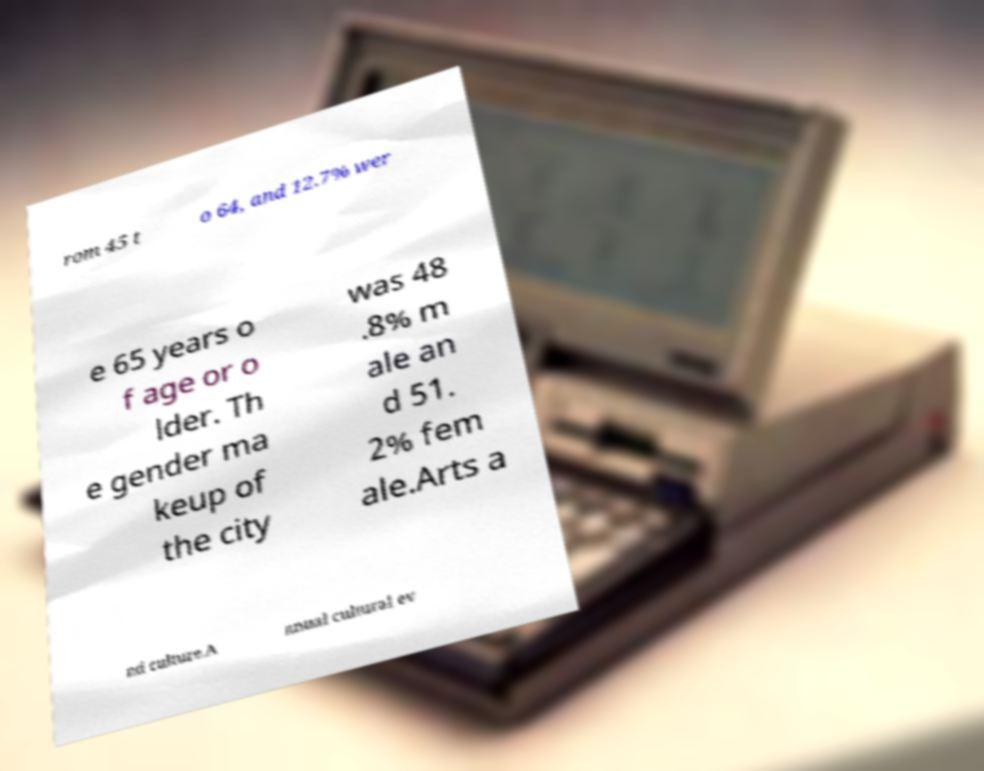Could you extract and type out the text from this image? rom 45 t o 64, and 12.7% wer e 65 years o f age or o lder. Th e gender ma keup of the city was 48 .8% m ale an d 51. 2% fem ale.Arts a nd culture.A nnual cultural ev 